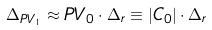<formula> <loc_0><loc_0><loc_500><loc_500>\Delta _ { P V _ { 1 } } \approx P V _ { 0 } \cdot \Delta _ { r } \equiv | C _ { 0 } | \cdot \Delta _ { r }</formula> 